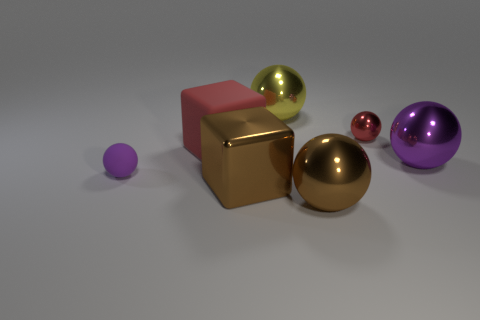The shiny object that is the same shape as the large matte object is what size?
Provide a succinct answer. Large. How many tiny metal spheres are the same color as the large matte object?
Your response must be concise. 1. What is the shape of the matte object that is behind the big purple metallic ball that is in front of the red metal ball?
Provide a succinct answer. Cube. What number of yellow balls are in front of the big yellow metal sphere?
Offer a very short reply. 0. There is a cube that is made of the same material as the tiny purple ball; what color is it?
Provide a short and direct response. Red. There is a yellow thing; is its size the same as the purple sphere that is on the right side of the red shiny ball?
Your answer should be very brief. Yes. There is a purple ball on the left side of the metal ball that is on the right side of the tiny object behind the purple metallic sphere; what size is it?
Ensure brevity in your answer.  Small. What number of rubber objects are tiny spheres or large brown cubes?
Offer a terse response. 1. What color is the tiny sphere left of the yellow metal sphere?
Give a very brief answer. Purple. The purple object that is the same size as the red metallic thing is what shape?
Provide a succinct answer. Sphere. 